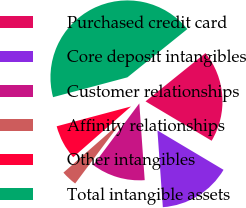Convert chart. <chart><loc_0><loc_0><loc_500><loc_500><pie_chart><fcel>Purchased credit card<fcel>Core deposit intangibles<fcel>Customer relationships<fcel>Affinity relationships<fcel>Other intangibles<fcel>Total intangible assets<nl><fcel>19.34%<fcel>15.33%<fcel>11.33%<fcel>3.32%<fcel>7.32%<fcel>43.36%<nl></chart> 